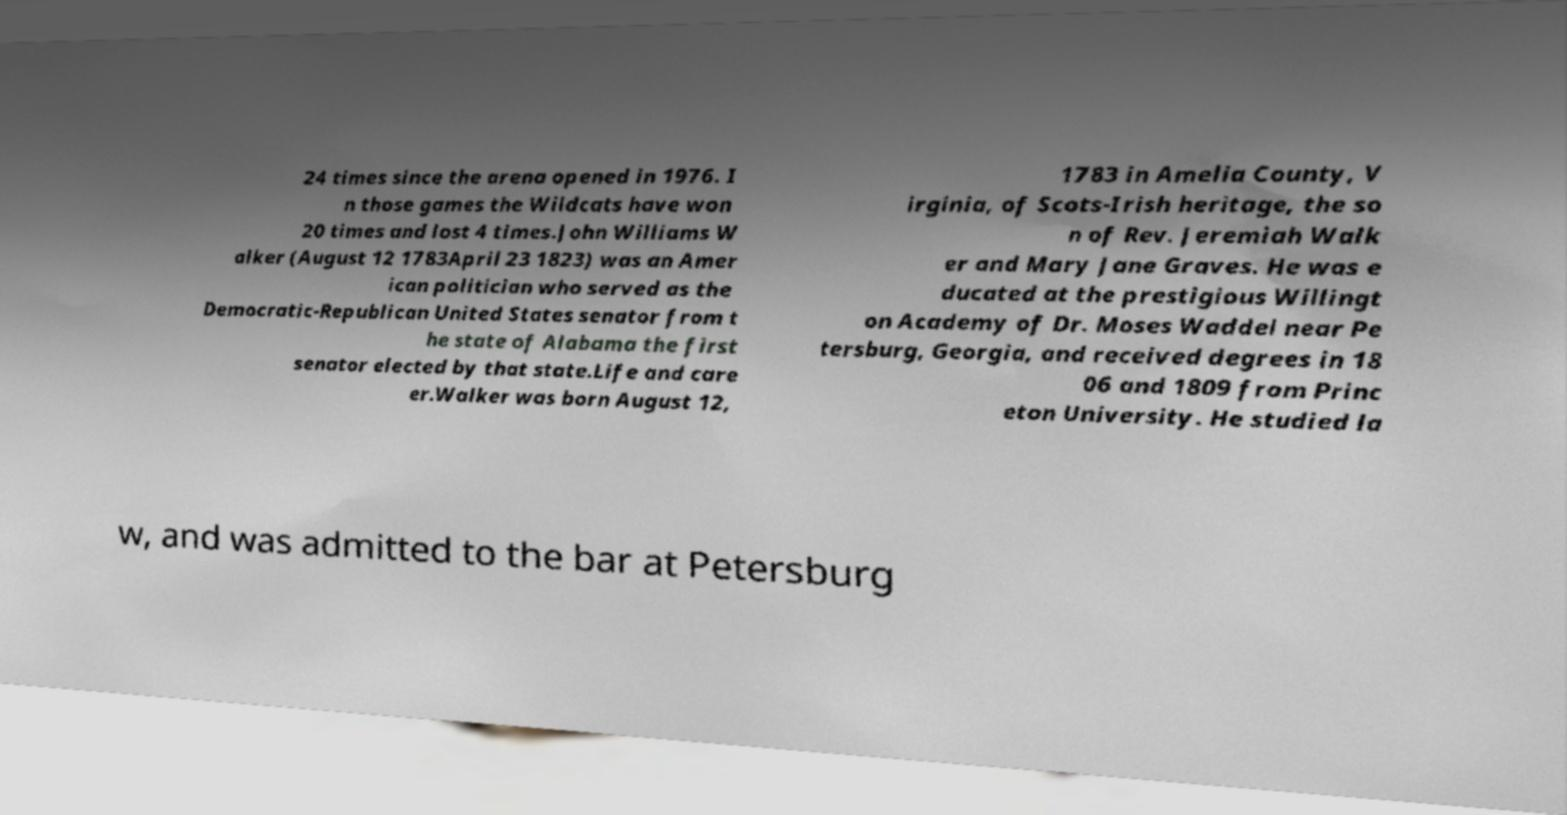Could you assist in decoding the text presented in this image and type it out clearly? 24 times since the arena opened in 1976. I n those games the Wildcats have won 20 times and lost 4 times.John Williams W alker (August 12 1783April 23 1823) was an Amer ican politician who served as the Democratic-Republican United States senator from t he state of Alabama the first senator elected by that state.Life and care er.Walker was born August 12, 1783 in Amelia County, V irginia, of Scots-Irish heritage, the so n of Rev. Jeremiah Walk er and Mary Jane Graves. He was e ducated at the prestigious Willingt on Academy of Dr. Moses Waddel near Pe tersburg, Georgia, and received degrees in 18 06 and 1809 from Princ eton University. He studied la w, and was admitted to the bar at Petersburg 